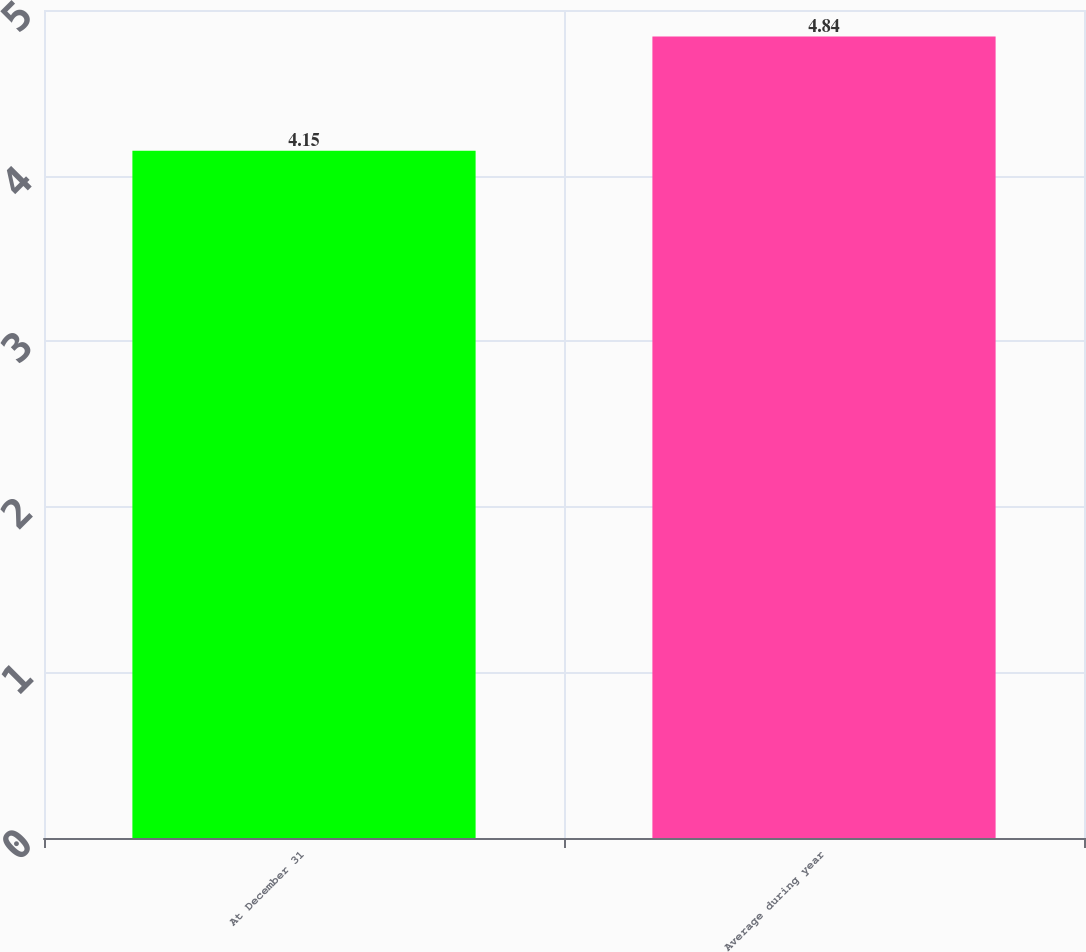Convert chart to OTSL. <chart><loc_0><loc_0><loc_500><loc_500><bar_chart><fcel>At December 31<fcel>Average during year<nl><fcel>4.15<fcel>4.84<nl></chart> 